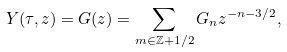<formula> <loc_0><loc_0><loc_500><loc_500>Y ( \tau , z ) = G ( z ) = \sum _ { m \in \mathbb { Z } + 1 / 2 } G _ { n } z ^ { - n - 3 / 2 } ,</formula> 